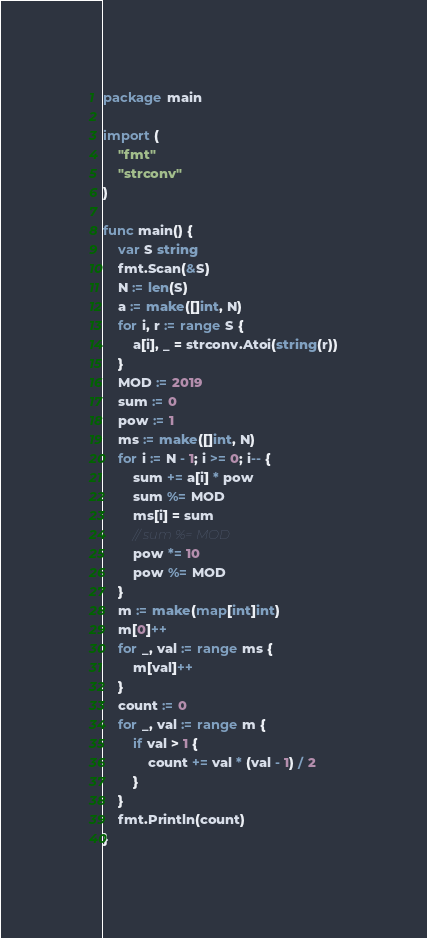<code> <loc_0><loc_0><loc_500><loc_500><_Go_>package main

import (
	"fmt"
	"strconv"
)

func main() {
	var S string
	fmt.Scan(&S)
	N := len(S)
	a := make([]int, N)
	for i, r := range S {
		a[i], _ = strconv.Atoi(string(r))
	}
	MOD := 2019
	sum := 0
	pow := 1
	ms := make([]int, N)
	for i := N - 1; i >= 0; i-- {
		sum += a[i] * pow
		sum %= MOD
		ms[i] = sum
		// sum %= MOD
		pow *= 10
		pow %= MOD
	}
	m := make(map[int]int)
	m[0]++
	for _, val := range ms {
		m[val]++
	}
	count := 0
	for _, val := range m {
		if val > 1 {
			count += val * (val - 1) / 2
		}
	}
	fmt.Println(count)
}
</code> 